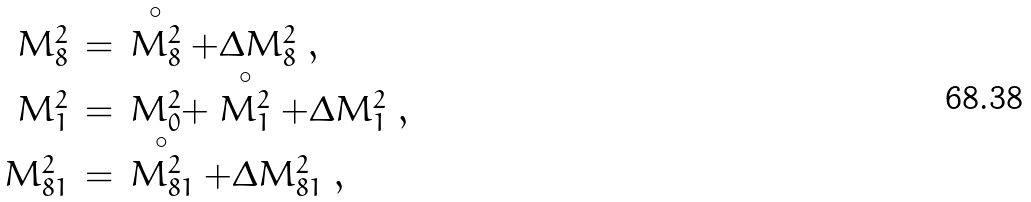<formula> <loc_0><loc_0><loc_500><loc_500>\begin{array} { r c l } M _ { 8 } ^ { 2 } & = & \stackrel { \circ } { M _ { 8 } ^ { 2 } } + \Delta M _ { 8 } ^ { 2 } \ , \\ M _ { 1 } ^ { 2 } & = & M _ { 0 } ^ { 2 } + \stackrel { \circ } { M _ { 1 } ^ { 2 } } + \Delta M _ { 1 } ^ { 2 } \ , \\ M _ { 8 1 } ^ { 2 } & = & \stackrel { \circ } { M _ { 8 1 } ^ { 2 } } + \Delta M _ { 8 1 } ^ { 2 } \ , \end{array}</formula> 